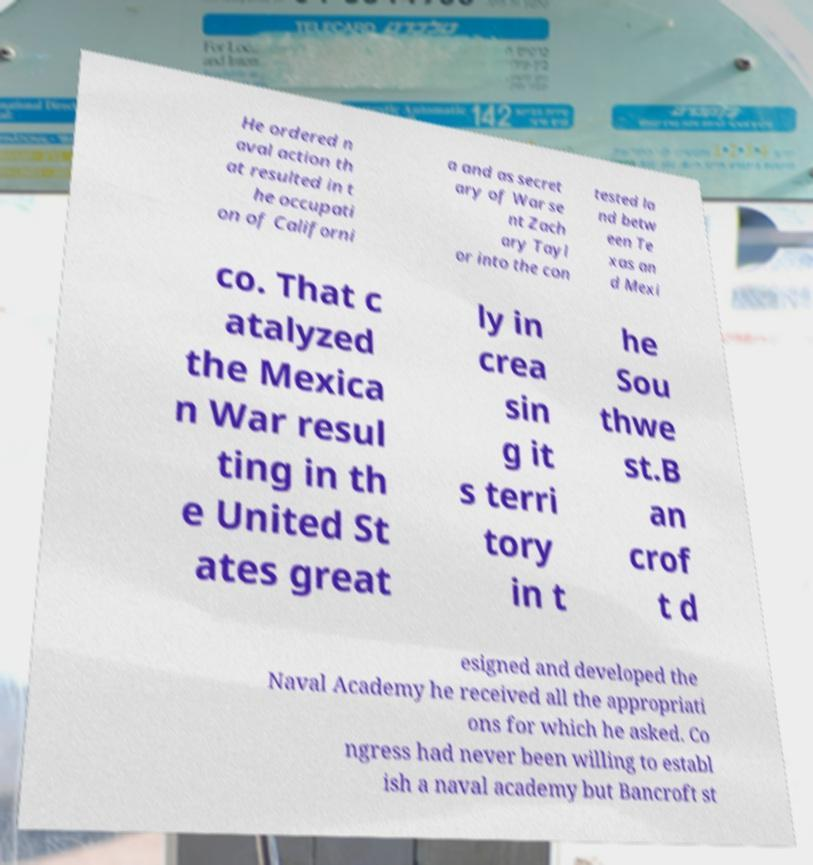Can you read and provide the text displayed in the image?This photo seems to have some interesting text. Can you extract and type it out for me? He ordered n aval action th at resulted in t he occupati on of Californi a and as secret ary of War se nt Zach ary Tayl or into the con tested la nd betw een Te xas an d Mexi co. That c atalyzed the Mexica n War resul ting in th e United St ates great ly in crea sin g it s terri tory in t he Sou thwe st.B an crof t d esigned and developed the Naval Academy he received all the appropriati ons for which he asked. Co ngress had never been willing to establ ish a naval academy but Bancroft st 